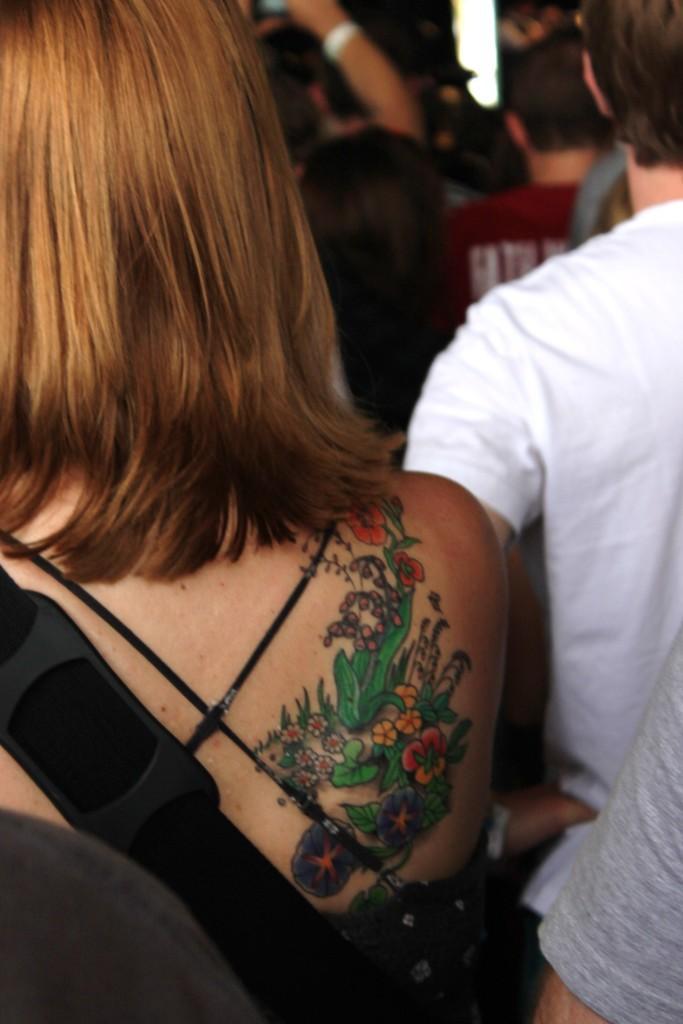In one or two sentences, can you explain what this image depicts? In this picture there is a tattoo on the woman and there are group of people. 